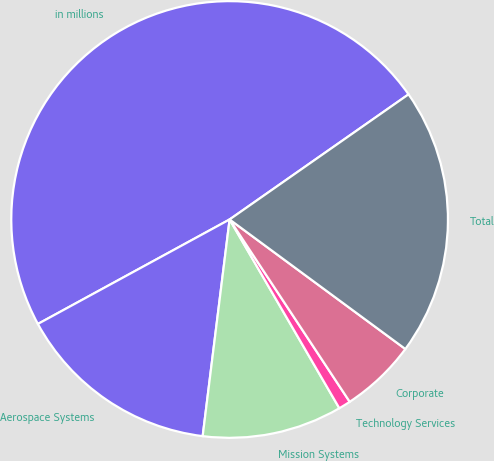Convert chart to OTSL. <chart><loc_0><loc_0><loc_500><loc_500><pie_chart><fcel>in millions<fcel>Aerospace Systems<fcel>Mission Systems<fcel>Technology Services<fcel>Corporate<fcel>Total<nl><fcel>48.23%<fcel>15.09%<fcel>10.35%<fcel>0.89%<fcel>5.62%<fcel>19.82%<nl></chart> 